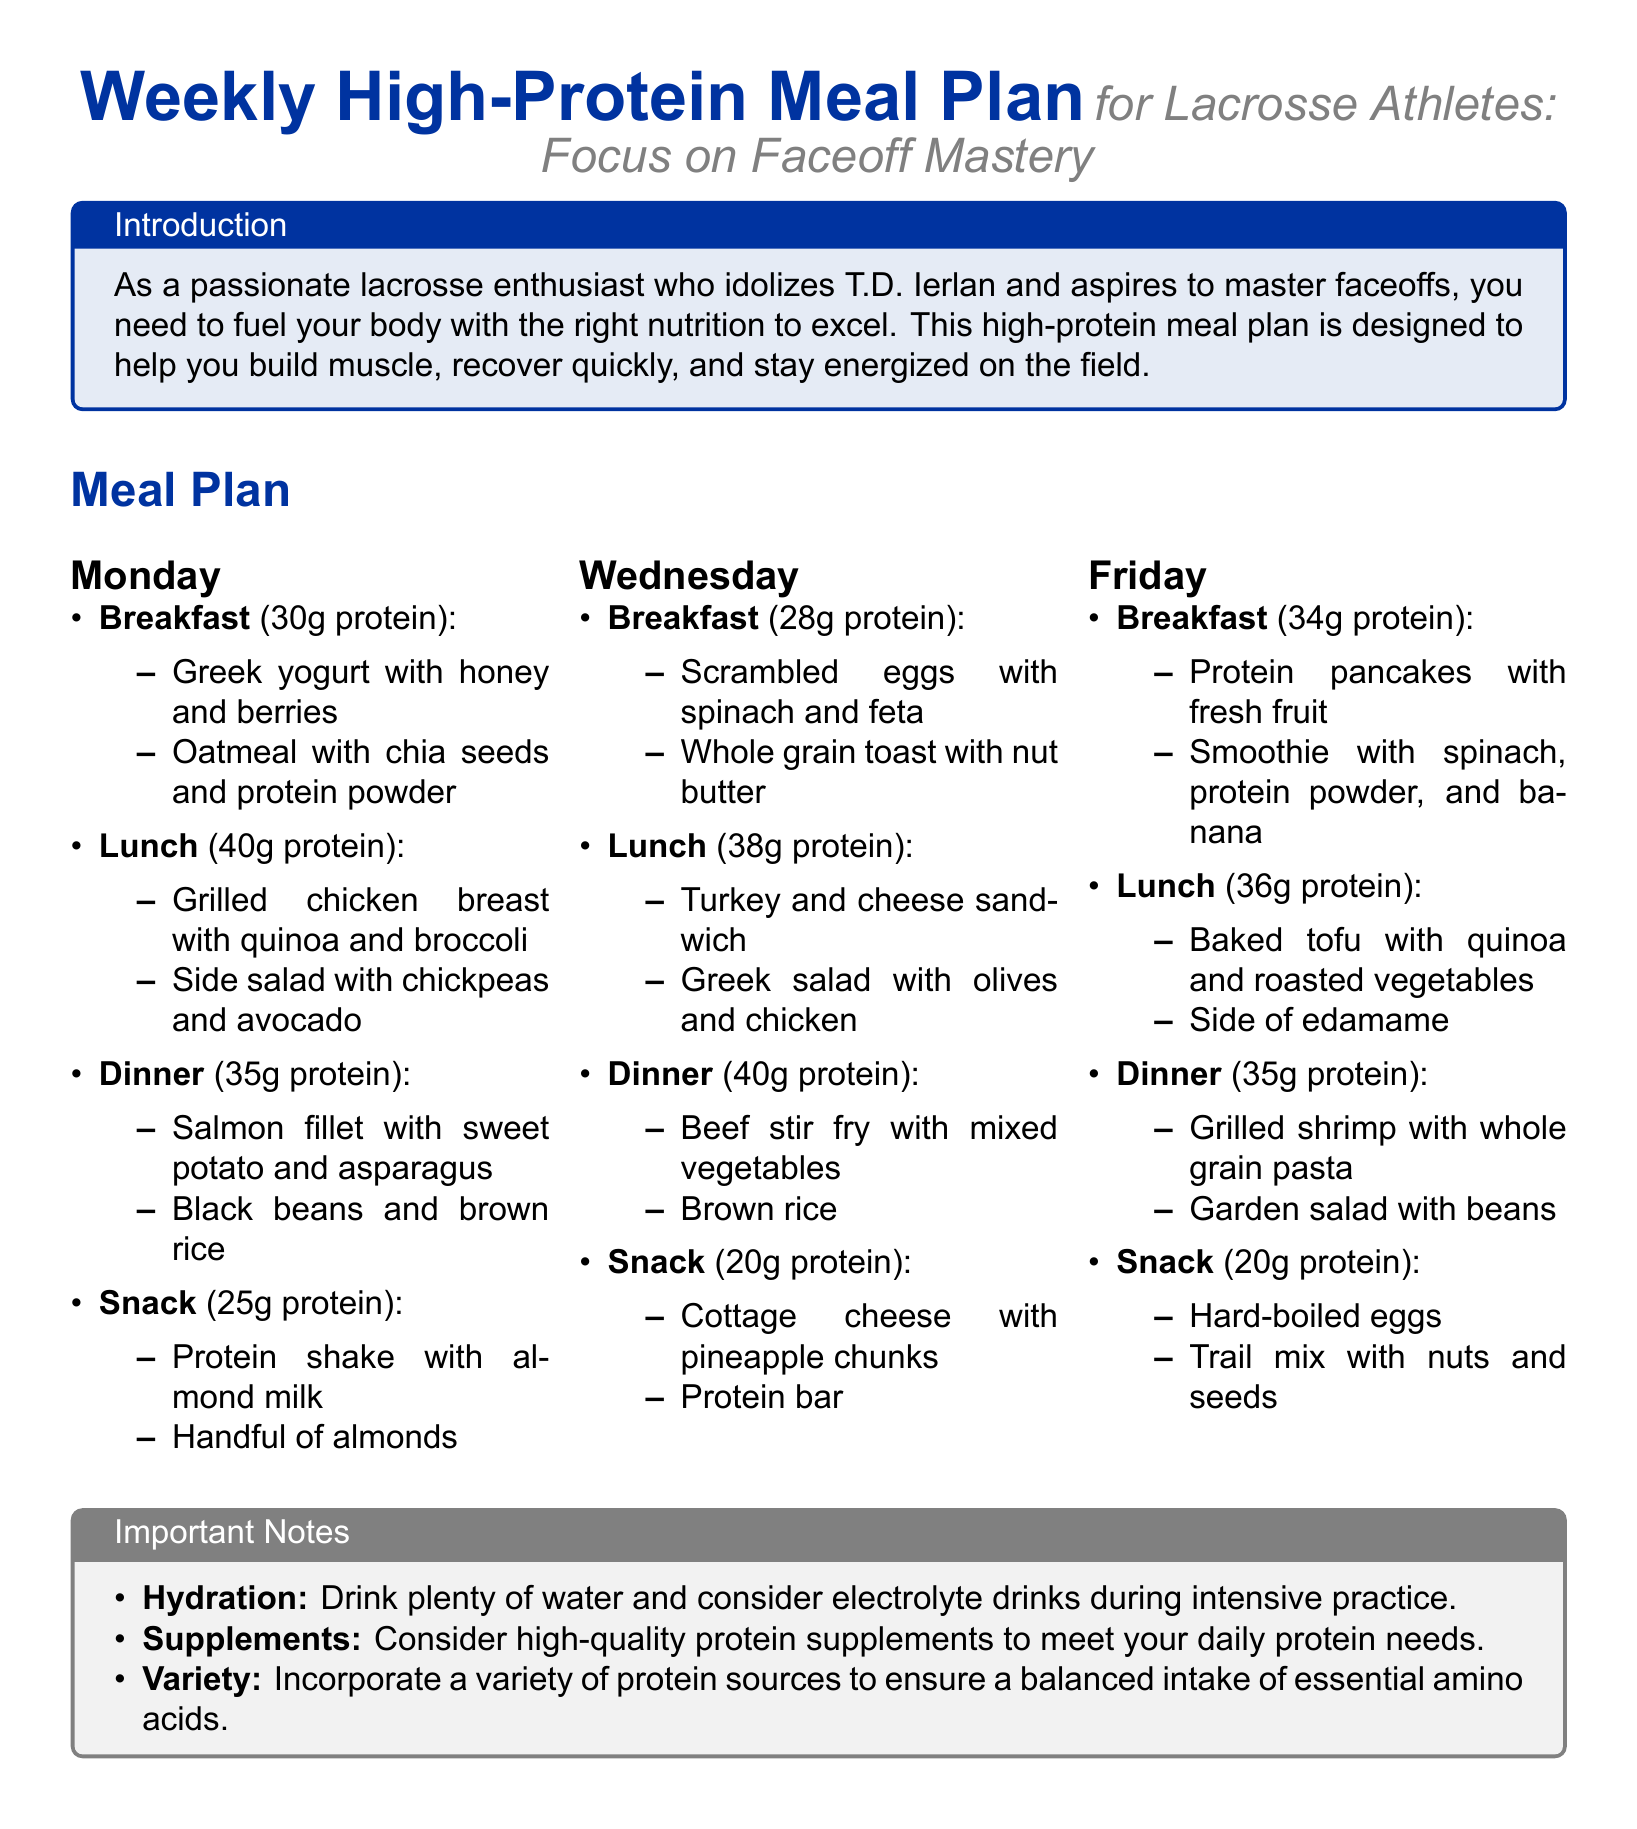What is the total protein for Monday's Lunch? The protein content for Monday's lunch is explicitly stated in the meal plan as 40g.
Answer: 40g What snack is suggested for Wednesday? The snack for Wednesday includes cottage cheese with pineapple chunks and a protein bar, which is specified in the meal plan.
Answer: Cottage cheese with pineapple chunks and protein bar How much protein do the protein pancakes provide on Friday's breakfast? The protein pancakes are detailed in the meal plan as providing 34g of protein.
Answer: 34g What is the focus of this meal plan? The document mentions that the meal plan focuses on faceoff mastery for lacrosse athletes.
Answer: Faceoff mastery What is one of the hydration tips mentioned? The document emphasizes drinking plenty of water and suggests considering electrolyte drinks during intensive practice.
Answer: Drink plenty of water What is included in the Saturday meal plan for lunch (if available)? There is no information about Saturday in the provided content, as the format only discusses Monday, Wednesday, and Friday.
Answer: Not available 